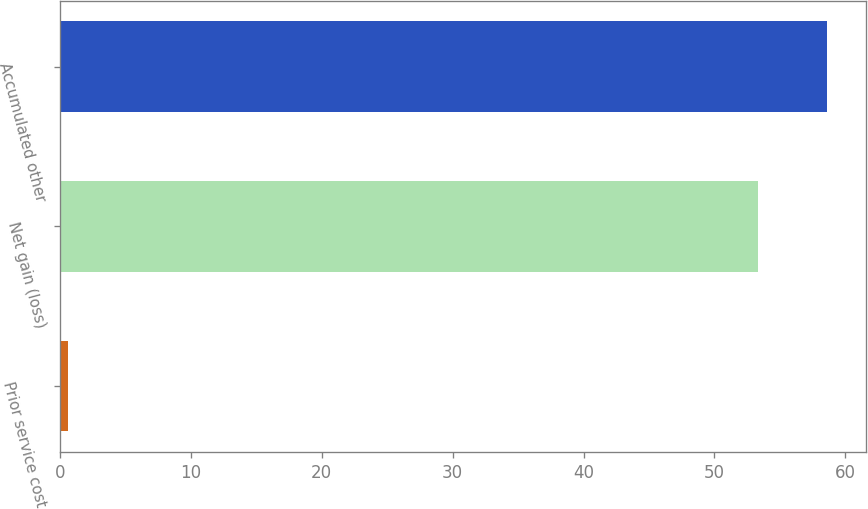Convert chart to OTSL. <chart><loc_0><loc_0><loc_500><loc_500><bar_chart><fcel>Prior service cost<fcel>Net gain (loss)<fcel>Accumulated other<nl><fcel>0.6<fcel>53.3<fcel>58.63<nl></chart> 